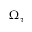Convert formula to latex. <formula><loc_0><loc_0><loc_500><loc_500>\Omega _ { \tau }</formula> 